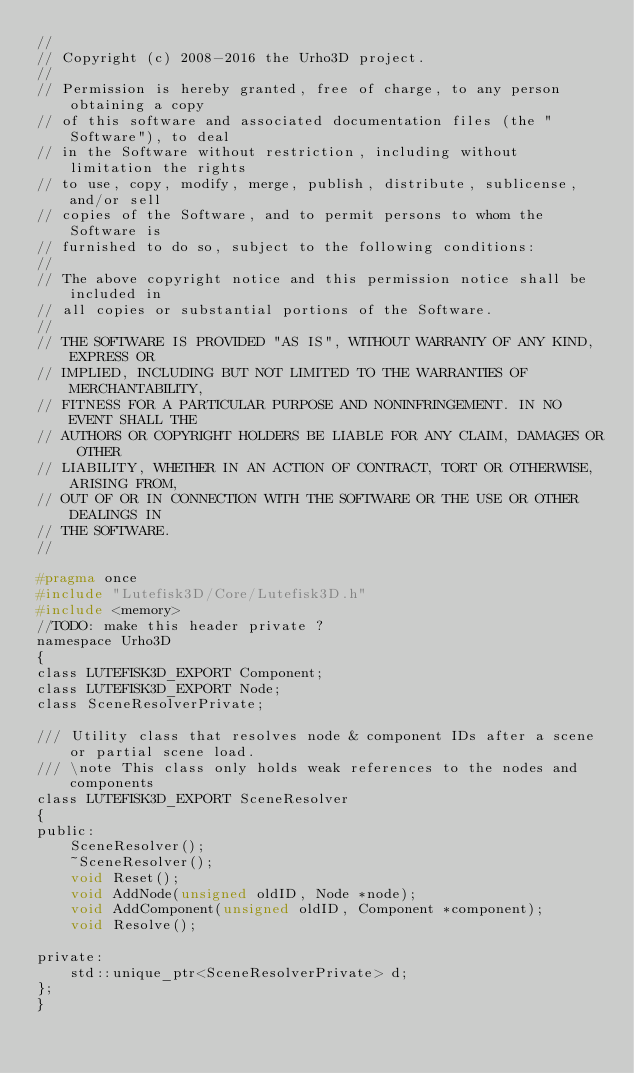<code> <loc_0><loc_0><loc_500><loc_500><_C_>//
// Copyright (c) 2008-2016 the Urho3D project.
//
// Permission is hereby granted, free of charge, to any person obtaining a copy
// of this software and associated documentation files (the "Software"), to deal
// in the Software without restriction, including without limitation the rights
// to use, copy, modify, merge, publish, distribute, sublicense, and/or sell
// copies of the Software, and to permit persons to whom the Software is
// furnished to do so, subject to the following conditions:
//
// The above copyright notice and this permission notice shall be included in
// all copies or substantial portions of the Software.
//
// THE SOFTWARE IS PROVIDED "AS IS", WITHOUT WARRANTY OF ANY KIND, EXPRESS OR
// IMPLIED, INCLUDING BUT NOT LIMITED TO THE WARRANTIES OF MERCHANTABILITY,
// FITNESS FOR A PARTICULAR PURPOSE AND NONINFRINGEMENT. IN NO EVENT SHALL THE
// AUTHORS OR COPYRIGHT HOLDERS BE LIABLE FOR ANY CLAIM, DAMAGES OR OTHER
// LIABILITY, WHETHER IN AN ACTION OF CONTRACT, TORT OR OTHERWISE, ARISING FROM,
// OUT OF OR IN CONNECTION WITH THE SOFTWARE OR THE USE OR OTHER DEALINGS IN
// THE SOFTWARE.
//

#pragma once
#include "Lutefisk3D/Core/Lutefisk3D.h"
#include <memory>
//TODO: make this header private ?
namespace Urho3D
{
class LUTEFISK3D_EXPORT Component;
class LUTEFISK3D_EXPORT Node;
class SceneResolverPrivate;

/// Utility class that resolves node & component IDs after a scene or partial scene load.
/// \note This class only holds weak references to the nodes and components
class LUTEFISK3D_EXPORT SceneResolver
{
public:
    SceneResolver();
    ~SceneResolver();
    void Reset();
    void AddNode(unsigned oldID, Node *node);
    void AddComponent(unsigned oldID, Component *component);
    void Resolve();

private:
    std::unique_ptr<SceneResolverPrivate> d;
};
}
</code> 